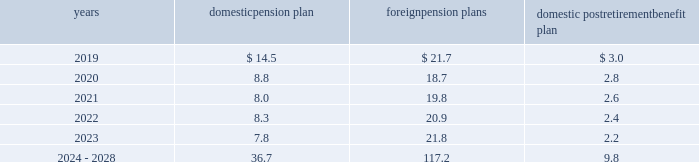Notes to consolidated financial statements 2013 ( continued ) ( amounts in millions , except per share amounts ) the estimated future benefit payments expected to be paid are presented below .
Domestic pension plan foreign pension plans domestic postretirement benefit plan .
The estimated future payments for our domestic postretirement benefit plan are net of any estimated u.s .
Federal subsidies expected to be received under the medicare prescription drug , improvement and modernization act of 2003 , which total no more than $ 0.3 in any individual year .
Savings plans we sponsor defined contribution plans ( the 201csavings plans 201d ) that cover substantially all domestic employees .
The savings plans permit participants to make contributions on a pre-tax and/or after-tax basis and allow participants to choose among various investment alternatives .
We match a portion of participant contributions based upon their years of service .
Amounts expensed for the savings plans for 2018 , 2017 and 2016 were $ 52.6 , $ 47.2 and $ 47.0 , respectively .
Expenses include a discretionary company contribution of $ 6.7 , $ 3.6 and $ 6.1 offset by participant forfeitures of $ 5.8 , $ 4.6 and $ 4.4 in 2018 , 2017 and 2016 , respectively .
In addition , we maintain defined contribution plans in various foreign countries and contributed $ 51.3 , $ 47.4 and $ 44.5 to these plans in 2018 , 2017 and 2016 , respectively .
Deferred compensation and benefit arrangements we have deferred compensation and benefit arrangements which ( i ) permit certain of our key officers and employees to defer a portion of their salary or incentive compensation or ( ii ) require us to contribute an amount to the participant 2019s account .
These arrangements may provide participants with the amounts deferred plus interest upon attaining certain conditions , such as completing a certain number of years of service , attaining a certain age or upon retirement or termination .
As of december 31 , 2018 and 2017 , the deferred compensation and deferred benefit liability balance was $ 196.2 and $ 213.2 , respectively .
Amounts expensed for deferred compensation and benefit arrangements in 2018 , 2017 and 2016 were $ 10.0 , $ 18.5 and $ 18.5 , respectively .
We have purchased life insurance policies on participants 2019 lives to assist in the funding of the related deferred compensation and deferred benefit liabilities .
As of december 31 , 2018 and 2017 , the cash surrender value of these policies was $ 177.3 and $ 177.4 , respectively .
Long-term disability plan we have a long-term disability plan which provides income replacement benefits to eligible participants who are unable to perform their job duties or any job related to his or her education , training or experience .
As all income replacement benefits are fully insured , no related obligation is required as of december 31 , 2018 and 2017 .
In addition to income replacement benefits , plan participants may remain covered for certain health and life insurance benefits up to normal retirement age , and accordingly , we have recorded an obligation of $ 5.9 and $ 8.4 as of december 31 , 2018 and 2017 , respectively. .
In 2018 what was the net discretionary company contribution after the participant forfeitures? 
Computations: (6.7 - 5.8)
Answer: 0.9. Notes to consolidated financial statements 2013 ( continued ) ( amounts in millions , except per share amounts ) the estimated future benefit payments expected to be paid are presented below .
Domestic pension plan foreign pension plans domestic postretirement benefit plan .
The estimated future payments for our domestic postretirement benefit plan are net of any estimated u.s .
Federal subsidies expected to be received under the medicare prescription drug , improvement and modernization act of 2003 , which total no more than $ 0.3 in any individual year .
Savings plans we sponsor defined contribution plans ( the 201csavings plans 201d ) that cover substantially all domestic employees .
The savings plans permit participants to make contributions on a pre-tax and/or after-tax basis and allow participants to choose among various investment alternatives .
We match a portion of participant contributions based upon their years of service .
Amounts expensed for the savings plans for 2018 , 2017 and 2016 were $ 52.6 , $ 47.2 and $ 47.0 , respectively .
Expenses include a discretionary company contribution of $ 6.7 , $ 3.6 and $ 6.1 offset by participant forfeitures of $ 5.8 , $ 4.6 and $ 4.4 in 2018 , 2017 and 2016 , respectively .
In addition , we maintain defined contribution plans in various foreign countries and contributed $ 51.3 , $ 47.4 and $ 44.5 to these plans in 2018 , 2017 and 2016 , respectively .
Deferred compensation and benefit arrangements we have deferred compensation and benefit arrangements which ( i ) permit certain of our key officers and employees to defer a portion of their salary or incentive compensation or ( ii ) require us to contribute an amount to the participant 2019s account .
These arrangements may provide participants with the amounts deferred plus interest upon attaining certain conditions , such as completing a certain number of years of service , attaining a certain age or upon retirement or termination .
As of december 31 , 2018 and 2017 , the deferred compensation and deferred benefit liability balance was $ 196.2 and $ 213.2 , respectively .
Amounts expensed for deferred compensation and benefit arrangements in 2018 , 2017 and 2016 were $ 10.0 , $ 18.5 and $ 18.5 , respectively .
We have purchased life insurance policies on participants 2019 lives to assist in the funding of the related deferred compensation and deferred benefit liabilities .
As of december 31 , 2018 and 2017 , the cash surrender value of these policies was $ 177.3 and $ 177.4 , respectively .
Long-term disability plan we have a long-term disability plan which provides income replacement benefits to eligible participants who are unable to perform their job duties or any job related to his or her education , training or experience .
As all income replacement benefits are fully insured , no related obligation is required as of december 31 , 2018 and 2017 .
In addition to income replacement benefits , plan participants may remain covered for certain health and life insurance benefits up to normal retirement age , and accordingly , we have recorded an obligation of $ 5.9 and $ 8.4 as of december 31 , 2018 and 2017 , respectively. .
What is the percentage decrease between the amounts expensed for deferred compensation and deferred benefit liability in 2017 and 2018? 
Computations: (((213.2 - 196.2) / 213.2) * 100)
Answer: 7.97373. Notes to consolidated financial statements 2013 ( continued ) ( amounts in millions , except per share amounts ) the estimated future benefit payments expected to be paid are presented below .
Domestic pension plan foreign pension plans domestic postretirement benefit plan .
The estimated future payments for our domestic postretirement benefit plan are net of any estimated u.s .
Federal subsidies expected to be received under the medicare prescription drug , improvement and modernization act of 2003 , which total no more than $ 0.3 in any individual year .
Savings plans we sponsor defined contribution plans ( the 201csavings plans 201d ) that cover substantially all domestic employees .
The savings plans permit participants to make contributions on a pre-tax and/or after-tax basis and allow participants to choose among various investment alternatives .
We match a portion of participant contributions based upon their years of service .
Amounts expensed for the savings plans for 2018 , 2017 and 2016 were $ 52.6 , $ 47.2 and $ 47.0 , respectively .
Expenses include a discretionary company contribution of $ 6.7 , $ 3.6 and $ 6.1 offset by participant forfeitures of $ 5.8 , $ 4.6 and $ 4.4 in 2018 , 2017 and 2016 , respectively .
In addition , we maintain defined contribution plans in various foreign countries and contributed $ 51.3 , $ 47.4 and $ 44.5 to these plans in 2018 , 2017 and 2016 , respectively .
Deferred compensation and benefit arrangements we have deferred compensation and benefit arrangements which ( i ) permit certain of our key officers and employees to defer a portion of their salary or incentive compensation or ( ii ) require us to contribute an amount to the participant 2019s account .
These arrangements may provide participants with the amounts deferred plus interest upon attaining certain conditions , such as completing a certain number of years of service , attaining a certain age or upon retirement or termination .
As of december 31 , 2018 and 2017 , the deferred compensation and deferred benefit liability balance was $ 196.2 and $ 213.2 , respectively .
Amounts expensed for deferred compensation and benefit arrangements in 2018 , 2017 and 2016 were $ 10.0 , $ 18.5 and $ 18.5 , respectively .
We have purchased life insurance policies on participants 2019 lives to assist in the funding of the related deferred compensation and deferred benefit liabilities .
As of december 31 , 2018 and 2017 , the cash surrender value of these policies was $ 177.3 and $ 177.4 , respectively .
Long-term disability plan we have a long-term disability plan which provides income replacement benefits to eligible participants who are unable to perform their job duties or any job related to his or her education , training or experience .
As all income replacement benefits are fully insured , no related obligation is required as of december 31 , 2018 and 2017 .
In addition to income replacement benefits , plan participants may remain covered for certain health and life insurance benefits up to normal retirement age , and accordingly , we have recorded an obligation of $ 5.9 and $ 8.4 as of december 31 , 2018 and 2017 , respectively. .
In 2019 what was the ratio of the foreign pension plan to the domestic pension plans? 
Computations: (21.7 / 14.5)
Answer: 1.49655. 